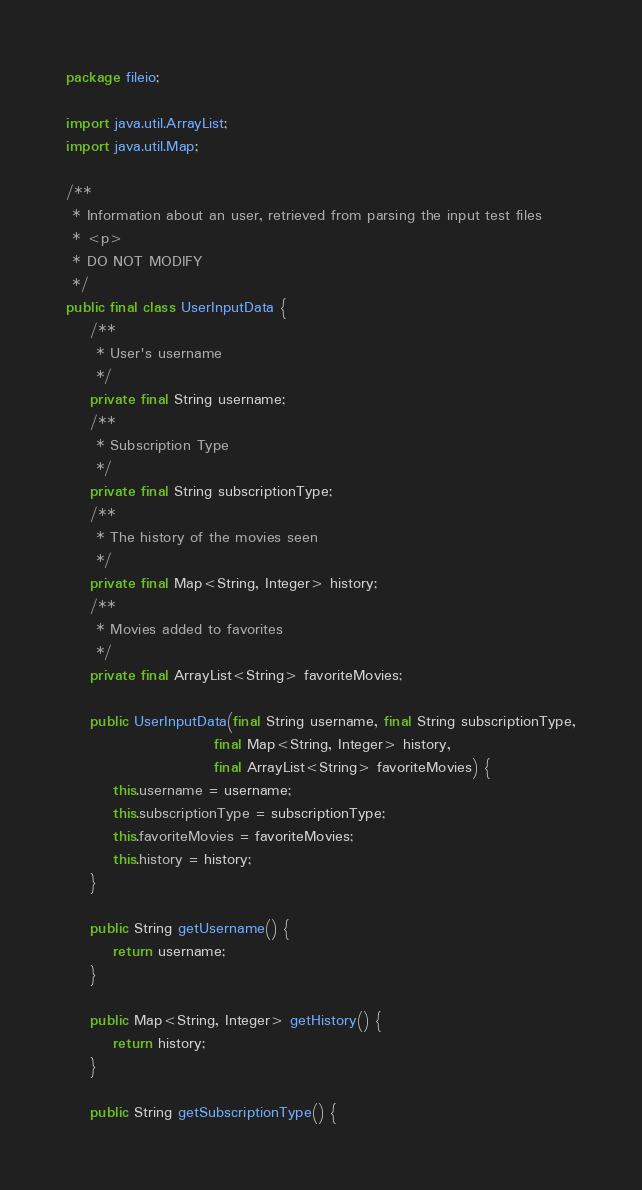<code> <loc_0><loc_0><loc_500><loc_500><_Java_>package fileio;

import java.util.ArrayList;
import java.util.Map;

/**
 * Information about an user, retrieved from parsing the input test files
 * <p>
 * DO NOT MODIFY
 */
public final class UserInputData {
    /**
     * User's username
     */
    private final String username;
    /**
     * Subscription Type
     */
    private final String subscriptionType;
    /**
     * The history of the movies seen
     */
    private final Map<String, Integer> history;
    /**
     * Movies added to favorites
     */
    private final ArrayList<String> favoriteMovies;

    public UserInputData(final String username, final String subscriptionType,
                         final Map<String, Integer> history,
                         final ArrayList<String> favoriteMovies) {
        this.username = username;
        this.subscriptionType = subscriptionType;
        this.favoriteMovies = favoriteMovies;
        this.history = history;
    }

    public String getUsername() {
        return username;
    }

    public Map<String, Integer> getHistory() {
        return history;
    }

    public String getSubscriptionType() {</code> 